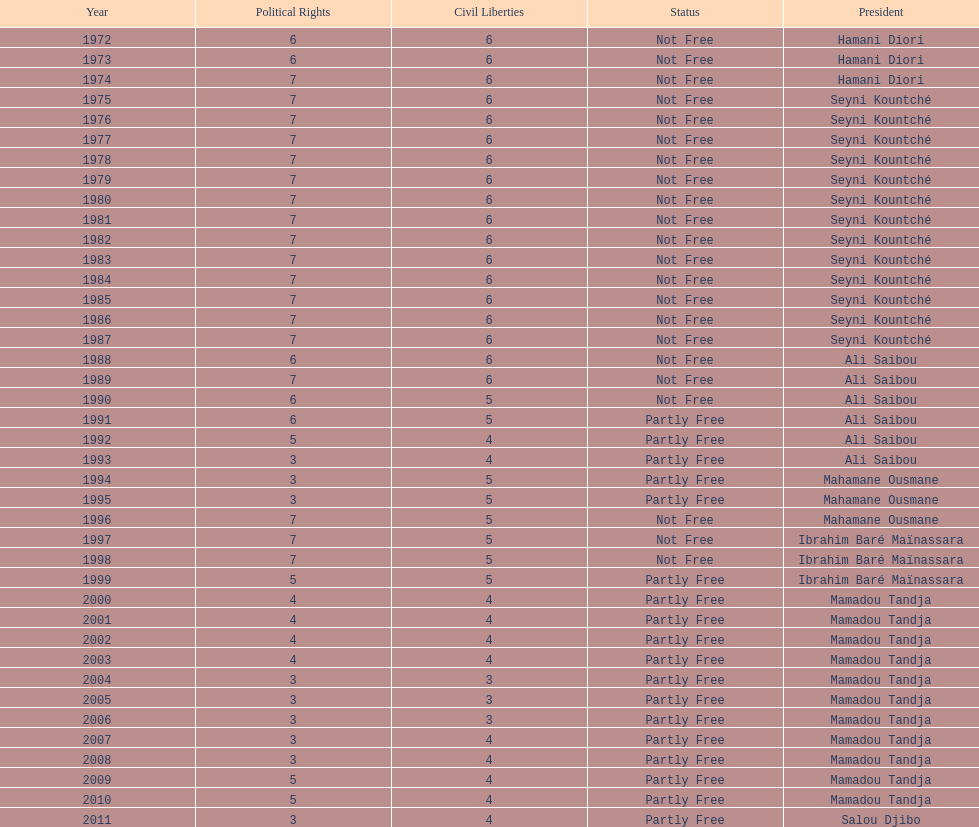Who held power for a longer duration, ali saibou or mamadou tandja? Mamadou Tandja. 